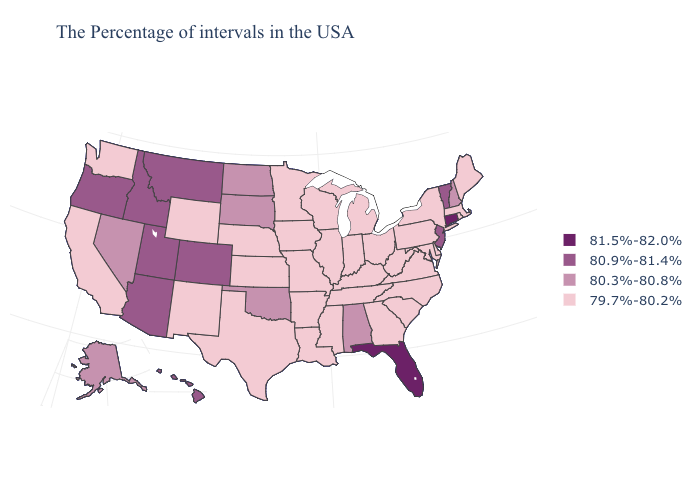Does Connecticut have the lowest value in the USA?
Answer briefly. No. Name the states that have a value in the range 80.9%-81.4%?
Quick response, please. Vermont, New Jersey, Colorado, Utah, Montana, Arizona, Idaho, Oregon, Hawaii. Does Indiana have a higher value than Montana?
Be succinct. No. Which states have the highest value in the USA?
Write a very short answer. Connecticut, Florida. Name the states that have a value in the range 80.3%-80.8%?
Quick response, please. New Hampshire, Alabama, Oklahoma, South Dakota, North Dakota, Nevada, Alaska. Does West Virginia have a lower value than Wisconsin?
Quick response, please. No. What is the highest value in the USA?
Quick response, please. 81.5%-82.0%. Name the states that have a value in the range 81.5%-82.0%?
Concise answer only. Connecticut, Florida. Name the states that have a value in the range 80.9%-81.4%?
Concise answer only. Vermont, New Jersey, Colorado, Utah, Montana, Arizona, Idaho, Oregon, Hawaii. Does Nevada have the same value as Georgia?
Answer briefly. No. What is the value of Michigan?
Give a very brief answer. 79.7%-80.2%. Among the states that border California , does Oregon have the highest value?
Quick response, please. Yes. What is the value of Iowa?
Write a very short answer. 79.7%-80.2%. What is the lowest value in the USA?
Concise answer only. 79.7%-80.2%. Among the states that border Iowa , which have the highest value?
Quick response, please. South Dakota. 